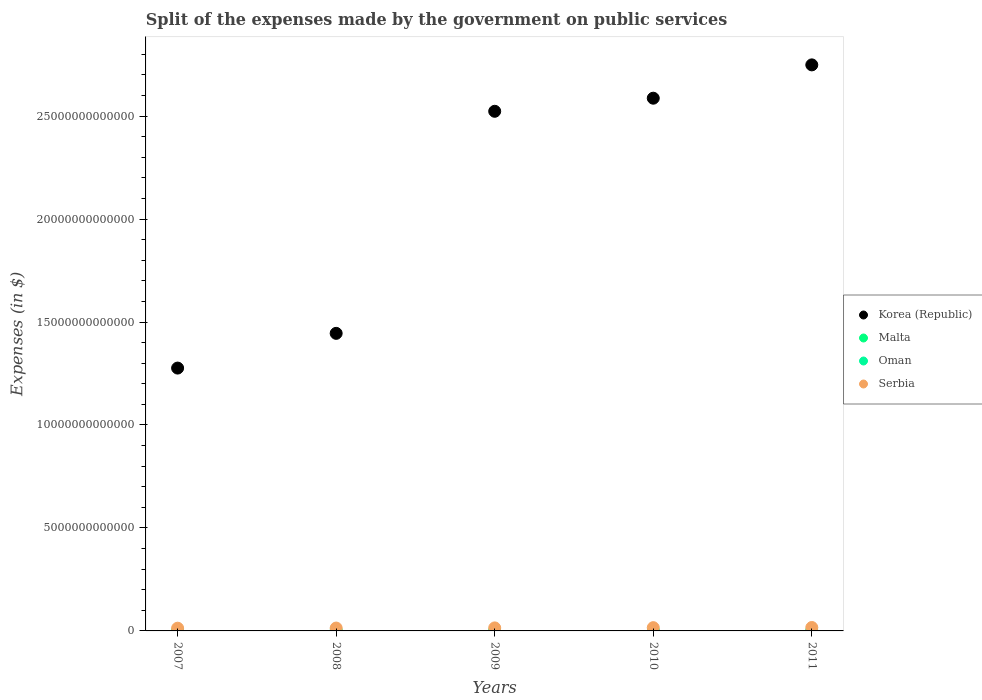What is the expenses made by the government on public services in Oman in 2011?
Offer a terse response. 3.99e+09. Across all years, what is the maximum expenses made by the government on public services in Korea (Republic)?
Provide a short and direct response. 2.75e+13. Across all years, what is the minimum expenses made by the government on public services in Oman?
Offer a very short reply. 2.47e+09. What is the total expenses made by the government on public services in Serbia in the graph?
Offer a terse response. 7.42e+11. What is the difference between the expenses made by the government on public services in Malta in 2007 and that in 2009?
Your answer should be compact. 3.03e+08. What is the difference between the expenses made by the government on public services in Oman in 2010 and the expenses made by the government on public services in Malta in 2009?
Keep it short and to the point. 2.88e+09. What is the average expenses made by the government on public services in Oman per year?
Your answer should be compact. 3.16e+09. In the year 2007, what is the difference between the expenses made by the government on public services in Serbia and expenses made by the government on public services in Malta?
Make the answer very short. 1.32e+11. What is the ratio of the expenses made by the government on public services in Malta in 2007 to that in 2009?
Ensure brevity in your answer.  1.94. What is the difference between the highest and the second highest expenses made by the government on public services in Oman?
Your response must be concise. 7.07e+08. What is the difference between the highest and the lowest expenses made by the government on public services in Serbia?
Your answer should be compact. 3.32e+1. In how many years, is the expenses made by the government on public services in Serbia greater than the average expenses made by the government on public services in Serbia taken over all years?
Your answer should be compact. 2. Is it the case that in every year, the sum of the expenses made by the government on public services in Oman and expenses made by the government on public services in Korea (Republic)  is greater than the sum of expenses made by the government on public services in Malta and expenses made by the government on public services in Serbia?
Offer a very short reply. Yes. Is the expenses made by the government on public services in Korea (Republic) strictly less than the expenses made by the government on public services in Malta over the years?
Give a very brief answer. No. What is the difference between two consecutive major ticks on the Y-axis?
Give a very brief answer. 5.00e+12. Are the values on the major ticks of Y-axis written in scientific E-notation?
Your answer should be compact. No. Does the graph contain any zero values?
Offer a terse response. No. Where does the legend appear in the graph?
Your response must be concise. Center right. How are the legend labels stacked?
Provide a succinct answer. Vertical. What is the title of the graph?
Offer a very short reply. Split of the expenses made by the government on public services. What is the label or title of the X-axis?
Give a very brief answer. Years. What is the label or title of the Y-axis?
Make the answer very short. Expenses (in $). What is the Expenses (in $) of Korea (Republic) in 2007?
Your answer should be compact. 1.28e+13. What is the Expenses (in $) in Malta in 2007?
Keep it short and to the point. 6.25e+08. What is the Expenses (in $) in Oman in 2007?
Provide a succinct answer. 2.47e+09. What is the Expenses (in $) of Serbia in 2007?
Provide a succinct answer. 1.32e+11. What is the Expenses (in $) in Korea (Republic) in 2008?
Give a very brief answer. 1.44e+13. What is the Expenses (in $) in Malta in 2008?
Provide a short and direct response. 3.59e+08. What is the Expenses (in $) of Oman in 2008?
Your answer should be compact. 3.28e+09. What is the Expenses (in $) in Serbia in 2008?
Offer a terse response. 1.39e+11. What is the Expenses (in $) in Korea (Republic) in 2009?
Your answer should be compact. 2.52e+13. What is the Expenses (in $) of Malta in 2009?
Offer a very short reply. 3.22e+08. What is the Expenses (in $) of Oman in 2009?
Give a very brief answer. 2.84e+09. What is the Expenses (in $) of Serbia in 2009?
Provide a short and direct response. 1.47e+11. What is the Expenses (in $) in Korea (Republic) in 2010?
Offer a very short reply. 2.59e+13. What is the Expenses (in $) in Malta in 2010?
Offer a very short reply. 3.41e+08. What is the Expenses (in $) of Oman in 2010?
Keep it short and to the point. 3.20e+09. What is the Expenses (in $) of Serbia in 2010?
Offer a very short reply. 1.58e+11. What is the Expenses (in $) of Korea (Republic) in 2011?
Make the answer very short. 2.75e+13. What is the Expenses (in $) of Malta in 2011?
Your answer should be compact. 3.76e+08. What is the Expenses (in $) in Oman in 2011?
Give a very brief answer. 3.99e+09. What is the Expenses (in $) of Serbia in 2011?
Keep it short and to the point. 1.66e+11. Across all years, what is the maximum Expenses (in $) of Korea (Republic)?
Offer a very short reply. 2.75e+13. Across all years, what is the maximum Expenses (in $) in Malta?
Your response must be concise. 6.25e+08. Across all years, what is the maximum Expenses (in $) in Oman?
Make the answer very short. 3.99e+09. Across all years, what is the maximum Expenses (in $) in Serbia?
Offer a very short reply. 1.66e+11. Across all years, what is the minimum Expenses (in $) in Korea (Republic)?
Your answer should be very brief. 1.28e+13. Across all years, what is the minimum Expenses (in $) in Malta?
Provide a succinct answer. 3.22e+08. Across all years, what is the minimum Expenses (in $) of Oman?
Make the answer very short. 2.47e+09. Across all years, what is the minimum Expenses (in $) of Serbia?
Ensure brevity in your answer.  1.32e+11. What is the total Expenses (in $) of Korea (Republic) in the graph?
Make the answer very short. 1.06e+14. What is the total Expenses (in $) of Malta in the graph?
Keep it short and to the point. 2.02e+09. What is the total Expenses (in $) in Oman in the graph?
Give a very brief answer. 1.58e+1. What is the total Expenses (in $) in Serbia in the graph?
Keep it short and to the point. 7.42e+11. What is the difference between the Expenses (in $) in Korea (Republic) in 2007 and that in 2008?
Provide a succinct answer. -1.69e+12. What is the difference between the Expenses (in $) of Malta in 2007 and that in 2008?
Your answer should be compact. 2.66e+08. What is the difference between the Expenses (in $) in Oman in 2007 and that in 2008?
Your response must be concise. -8.10e+08. What is the difference between the Expenses (in $) in Serbia in 2007 and that in 2008?
Ensure brevity in your answer.  -6.87e+09. What is the difference between the Expenses (in $) of Korea (Republic) in 2007 and that in 2009?
Ensure brevity in your answer.  -1.25e+13. What is the difference between the Expenses (in $) of Malta in 2007 and that in 2009?
Your response must be concise. 3.03e+08. What is the difference between the Expenses (in $) in Oman in 2007 and that in 2009?
Give a very brief answer. -3.66e+08. What is the difference between the Expenses (in $) in Serbia in 2007 and that in 2009?
Ensure brevity in your answer.  -1.44e+1. What is the difference between the Expenses (in $) in Korea (Republic) in 2007 and that in 2010?
Make the answer very short. -1.31e+13. What is the difference between the Expenses (in $) in Malta in 2007 and that in 2010?
Give a very brief answer. 2.84e+08. What is the difference between the Expenses (in $) in Oman in 2007 and that in 2010?
Offer a very short reply. -7.25e+08. What is the difference between the Expenses (in $) in Serbia in 2007 and that in 2010?
Provide a short and direct response. -2.59e+1. What is the difference between the Expenses (in $) of Korea (Republic) in 2007 and that in 2011?
Provide a short and direct response. -1.47e+13. What is the difference between the Expenses (in $) in Malta in 2007 and that in 2011?
Offer a very short reply. 2.49e+08. What is the difference between the Expenses (in $) of Oman in 2007 and that in 2011?
Make the answer very short. -1.52e+09. What is the difference between the Expenses (in $) in Serbia in 2007 and that in 2011?
Offer a very short reply. -3.32e+1. What is the difference between the Expenses (in $) in Korea (Republic) in 2008 and that in 2009?
Give a very brief answer. -1.08e+13. What is the difference between the Expenses (in $) of Malta in 2008 and that in 2009?
Offer a very short reply. 3.69e+07. What is the difference between the Expenses (in $) in Oman in 2008 and that in 2009?
Offer a very short reply. 4.44e+08. What is the difference between the Expenses (in $) of Serbia in 2008 and that in 2009?
Ensure brevity in your answer.  -7.48e+09. What is the difference between the Expenses (in $) of Korea (Republic) in 2008 and that in 2010?
Make the answer very short. -1.14e+13. What is the difference between the Expenses (in $) of Malta in 2008 and that in 2010?
Give a very brief answer. 1.82e+07. What is the difference between the Expenses (in $) of Oman in 2008 and that in 2010?
Provide a short and direct response. 8.54e+07. What is the difference between the Expenses (in $) in Serbia in 2008 and that in 2010?
Ensure brevity in your answer.  -1.90e+1. What is the difference between the Expenses (in $) in Korea (Republic) in 2008 and that in 2011?
Give a very brief answer. -1.30e+13. What is the difference between the Expenses (in $) in Malta in 2008 and that in 2011?
Give a very brief answer. -1.72e+07. What is the difference between the Expenses (in $) of Oman in 2008 and that in 2011?
Your answer should be compact. -7.07e+08. What is the difference between the Expenses (in $) of Serbia in 2008 and that in 2011?
Offer a very short reply. -2.63e+1. What is the difference between the Expenses (in $) in Korea (Republic) in 2009 and that in 2010?
Provide a short and direct response. -6.35e+11. What is the difference between the Expenses (in $) in Malta in 2009 and that in 2010?
Ensure brevity in your answer.  -1.87e+07. What is the difference between the Expenses (in $) of Oman in 2009 and that in 2010?
Make the answer very short. -3.58e+08. What is the difference between the Expenses (in $) in Serbia in 2009 and that in 2010?
Provide a succinct answer. -1.15e+1. What is the difference between the Expenses (in $) of Korea (Republic) in 2009 and that in 2011?
Your response must be concise. -2.25e+12. What is the difference between the Expenses (in $) of Malta in 2009 and that in 2011?
Provide a succinct answer. -5.41e+07. What is the difference between the Expenses (in $) of Oman in 2009 and that in 2011?
Give a very brief answer. -1.15e+09. What is the difference between the Expenses (in $) in Serbia in 2009 and that in 2011?
Give a very brief answer. -1.89e+1. What is the difference between the Expenses (in $) in Korea (Republic) in 2010 and that in 2011?
Your answer should be compact. -1.62e+12. What is the difference between the Expenses (in $) in Malta in 2010 and that in 2011?
Keep it short and to the point. -3.53e+07. What is the difference between the Expenses (in $) of Oman in 2010 and that in 2011?
Offer a very short reply. -7.93e+08. What is the difference between the Expenses (in $) of Serbia in 2010 and that in 2011?
Give a very brief answer. -7.33e+09. What is the difference between the Expenses (in $) in Korea (Republic) in 2007 and the Expenses (in $) in Malta in 2008?
Ensure brevity in your answer.  1.28e+13. What is the difference between the Expenses (in $) in Korea (Republic) in 2007 and the Expenses (in $) in Oman in 2008?
Keep it short and to the point. 1.28e+13. What is the difference between the Expenses (in $) in Korea (Republic) in 2007 and the Expenses (in $) in Serbia in 2008?
Ensure brevity in your answer.  1.26e+13. What is the difference between the Expenses (in $) of Malta in 2007 and the Expenses (in $) of Oman in 2008?
Provide a short and direct response. -2.66e+09. What is the difference between the Expenses (in $) in Malta in 2007 and the Expenses (in $) in Serbia in 2008?
Your response must be concise. -1.39e+11. What is the difference between the Expenses (in $) of Oman in 2007 and the Expenses (in $) of Serbia in 2008?
Keep it short and to the point. -1.37e+11. What is the difference between the Expenses (in $) of Korea (Republic) in 2007 and the Expenses (in $) of Malta in 2009?
Provide a succinct answer. 1.28e+13. What is the difference between the Expenses (in $) of Korea (Republic) in 2007 and the Expenses (in $) of Oman in 2009?
Your response must be concise. 1.28e+13. What is the difference between the Expenses (in $) of Korea (Republic) in 2007 and the Expenses (in $) of Serbia in 2009?
Provide a succinct answer. 1.26e+13. What is the difference between the Expenses (in $) of Malta in 2007 and the Expenses (in $) of Oman in 2009?
Provide a short and direct response. -2.22e+09. What is the difference between the Expenses (in $) in Malta in 2007 and the Expenses (in $) in Serbia in 2009?
Ensure brevity in your answer.  -1.46e+11. What is the difference between the Expenses (in $) of Oman in 2007 and the Expenses (in $) of Serbia in 2009?
Offer a terse response. -1.44e+11. What is the difference between the Expenses (in $) in Korea (Republic) in 2007 and the Expenses (in $) in Malta in 2010?
Ensure brevity in your answer.  1.28e+13. What is the difference between the Expenses (in $) of Korea (Republic) in 2007 and the Expenses (in $) of Oman in 2010?
Make the answer very short. 1.28e+13. What is the difference between the Expenses (in $) in Korea (Republic) in 2007 and the Expenses (in $) in Serbia in 2010?
Your answer should be very brief. 1.26e+13. What is the difference between the Expenses (in $) in Malta in 2007 and the Expenses (in $) in Oman in 2010?
Keep it short and to the point. -2.57e+09. What is the difference between the Expenses (in $) in Malta in 2007 and the Expenses (in $) in Serbia in 2010?
Ensure brevity in your answer.  -1.58e+11. What is the difference between the Expenses (in $) in Oman in 2007 and the Expenses (in $) in Serbia in 2010?
Ensure brevity in your answer.  -1.56e+11. What is the difference between the Expenses (in $) in Korea (Republic) in 2007 and the Expenses (in $) in Malta in 2011?
Make the answer very short. 1.28e+13. What is the difference between the Expenses (in $) in Korea (Republic) in 2007 and the Expenses (in $) in Oman in 2011?
Make the answer very short. 1.28e+13. What is the difference between the Expenses (in $) of Korea (Republic) in 2007 and the Expenses (in $) of Serbia in 2011?
Make the answer very short. 1.26e+13. What is the difference between the Expenses (in $) in Malta in 2007 and the Expenses (in $) in Oman in 2011?
Offer a very short reply. -3.37e+09. What is the difference between the Expenses (in $) of Malta in 2007 and the Expenses (in $) of Serbia in 2011?
Offer a terse response. -1.65e+11. What is the difference between the Expenses (in $) of Oman in 2007 and the Expenses (in $) of Serbia in 2011?
Give a very brief answer. -1.63e+11. What is the difference between the Expenses (in $) of Korea (Republic) in 2008 and the Expenses (in $) of Malta in 2009?
Offer a very short reply. 1.44e+13. What is the difference between the Expenses (in $) in Korea (Republic) in 2008 and the Expenses (in $) in Oman in 2009?
Offer a terse response. 1.44e+13. What is the difference between the Expenses (in $) in Korea (Republic) in 2008 and the Expenses (in $) in Serbia in 2009?
Offer a terse response. 1.43e+13. What is the difference between the Expenses (in $) of Malta in 2008 and the Expenses (in $) of Oman in 2009?
Offer a terse response. -2.48e+09. What is the difference between the Expenses (in $) in Malta in 2008 and the Expenses (in $) in Serbia in 2009?
Offer a very short reply. -1.46e+11. What is the difference between the Expenses (in $) in Oman in 2008 and the Expenses (in $) in Serbia in 2009?
Offer a very short reply. -1.43e+11. What is the difference between the Expenses (in $) in Korea (Republic) in 2008 and the Expenses (in $) in Malta in 2010?
Provide a short and direct response. 1.44e+13. What is the difference between the Expenses (in $) of Korea (Republic) in 2008 and the Expenses (in $) of Oman in 2010?
Your answer should be very brief. 1.44e+13. What is the difference between the Expenses (in $) in Korea (Republic) in 2008 and the Expenses (in $) in Serbia in 2010?
Make the answer very short. 1.43e+13. What is the difference between the Expenses (in $) in Malta in 2008 and the Expenses (in $) in Oman in 2010?
Offer a terse response. -2.84e+09. What is the difference between the Expenses (in $) in Malta in 2008 and the Expenses (in $) in Serbia in 2010?
Provide a short and direct response. -1.58e+11. What is the difference between the Expenses (in $) in Oman in 2008 and the Expenses (in $) in Serbia in 2010?
Offer a very short reply. -1.55e+11. What is the difference between the Expenses (in $) in Korea (Republic) in 2008 and the Expenses (in $) in Malta in 2011?
Make the answer very short. 1.44e+13. What is the difference between the Expenses (in $) in Korea (Republic) in 2008 and the Expenses (in $) in Oman in 2011?
Offer a very short reply. 1.44e+13. What is the difference between the Expenses (in $) in Korea (Republic) in 2008 and the Expenses (in $) in Serbia in 2011?
Offer a terse response. 1.43e+13. What is the difference between the Expenses (in $) of Malta in 2008 and the Expenses (in $) of Oman in 2011?
Give a very brief answer. -3.63e+09. What is the difference between the Expenses (in $) in Malta in 2008 and the Expenses (in $) in Serbia in 2011?
Your answer should be compact. -1.65e+11. What is the difference between the Expenses (in $) in Oman in 2008 and the Expenses (in $) in Serbia in 2011?
Offer a terse response. -1.62e+11. What is the difference between the Expenses (in $) of Korea (Republic) in 2009 and the Expenses (in $) of Malta in 2010?
Make the answer very short. 2.52e+13. What is the difference between the Expenses (in $) in Korea (Republic) in 2009 and the Expenses (in $) in Oman in 2010?
Make the answer very short. 2.52e+13. What is the difference between the Expenses (in $) in Korea (Republic) in 2009 and the Expenses (in $) in Serbia in 2010?
Give a very brief answer. 2.51e+13. What is the difference between the Expenses (in $) of Malta in 2009 and the Expenses (in $) of Oman in 2010?
Make the answer very short. -2.88e+09. What is the difference between the Expenses (in $) of Malta in 2009 and the Expenses (in $) of Serbia in 2010?
Your answer should be very brief. -1.58e+11. What is the difference between the Expenses (in $) in Oman in 2009 and the Expenses (in $) in Serbia in 2010?
Your answer should be very brief. -1.55e+11. What is the difference between the Expenses (in $) in Korea (Republic) in 2009 and the Expenses (in $) in Malta in 2011?
Keep it short and to the point. 2.52e+13. What is the difference between the Expenses (in $) of Korea (Republic) in 2009 and the Expenses (in $) of Oman in 2011?
Your response must be concise. 2.52e+13. What is the difference between the Expenses (in $) of Korea (Republic) in 2009 and the Expenses (in $) of Serbia in 2011?
Your answer should be very brief. 2.51e+13. What is the difference between the Expenses (in $) in Malta in 2009 and the Expenses (in $) in Oman in 2011?
Your answer should be compact. -3.67e+09. What is the difference between the Expenses (in $) of Malta in 2009 and the Expenses (in $) of Serbia in 2011?
Make the answer very short. -1.65e+11. What is the difference between the Expenses (in $) in Oman in 2009 and the Expenses (in $) in Serbia in 2011?
Ensure brevity in your answer.  -1.63e+11. What is the difference between the Expenses (in $) in Korea (Republic) in 2010 and the Expenses (in $) in Malta in 2011?
Make the answer very short. 2.59e+13. What is the difference between the Expenses (in $) of Korea (Republic) in 2010 and the Expenses (in $) of Oman in 2011?
Your answer should be compact. 2.59e+13. What is the difference between the Expenses (in $) in Korea (Republic) in 2010 and the Expenses (in $) in Serbia in 2011?
Offer a terse response. 2.57e+13. What is the difference between the Expenses (in $) in Malta in 2010 and the Expenses (in $) in Oman in 2011?
Offer a very short reply. -3.65e+09. What is the difference between the Expenses (in $) in Malta in 2010 and the Expenses (in $) in Serbia in 2011?
Your response must be concise. -1.65e+11. What is the difference between the Expenses (in $) of Oman in 2010 and the Expenses (in $) of Serbia in 2011?
Offer a terse response. -1.62e+11. What is the average Expenses (in $) in Korea (Republic) per year?
Provide a succinct answer. 2.12e+13. What is the average Expenses (in $) in Malta per year?
Give a very brief answer. 4.05e+08. What is the average Expenses (in $) in Oman per year?
Keep it short and to the point. 3.16e+09. What is the average Expenses (in $) in Serbia per year?
Keep it short and to the point. 1.48e+11. In the year 2007, what is the difference between the Expenses (in $) in Korea (Republic) and Expenses (in $) in Malta?
Offer a very short reply. 1.28e+13. In the year 2007, what is the difference between the Expenses (in $) of Korea (Republic) and Expenses (in $) of Oman?
Provide a succinct answer. 1.28e+13. In the year 2007, what is the difference between the Expenses (in $) in Korea (Republic) and Expenses (in $) in Serbia?
Offer a terse response. 1.26e+13. In the year 2007, what is the difference between the Expenses (in $) of Malta and Expenses (in $) of Oman?
Your response must be concise. -1.85e+09. In the year 2007, what is the difference between the Expenses (in $) in Malta and Expenses (in $) in Serbia?
Your answer should be very brief. -1.32e+11. In the year 2007, what is the difference between the Expenses (in $) in Oman and Expenses (in $) in Serbia?
Make the answer very short. -1.30e+11. In the year 2008, what is the difference between the Expenses (in $) of Korea (Republic) and Expenses (in $) of Malta?
Offer a very short reply. 1.44e+13. In the year 2008, what is the difference between the Expenses (in $) in Korea (Republic) and Expenses (in $) in Oman?
Make the answer very short. 1.44e+13. In the year 2008, what is the difference between the Expenses (in $) of Korea (Republic) and Expenses (in $) of Serbia?
Make the answer very short. 1.43e+13. In the year 2008, what is the difference between the Expenses (in $) of Malta and Expenses (in $) of Oman?
Offer a terse response. -2.93e+09. In the year 2008, what is the difference between the Expenses (in $) in Malta and Expenses (in $) in Serbia?
Provide a short and direct response. -1.39e+11. In the year 2008, what is the difference between the Expenses (in $) of Oman and Expenses (in $) of Serbia?
Provide a succinct answer. -1.36e+11. In the year 2009, what is the difference between the Expenses (in $) in Korea (Republic) and Expenses (in $) in Malta?
Make the answer very short. 2.52e+13. In the year 2009, what is the difference between the Expenses (in $) in Korea (Republic) and Expenses (in $) in Oman?
Offer a terse response. 2.52e+13. In the year 2009, what is the difference between the Expenses (in $) of Korea (Republic) and Expenses (in $) of Serbia?
Ensure brevity in your answer.  2.51e+13. In the year 2009, what is the difference between the Expenses (in $) in Malta and Expenses (in $) in Oman?
Provide a succinct answer. -2.52e+09. In the year 2009, what is the difference between the Expenses (in $) in Malta and Expenses (in $) in Serbia?
Offer a very short reply. -1.46e+11. In the year 2009, what is the difference between the Expenses (in $) in Oman and Expenses (in $) in Serbia?
Make the answer very short. -1.44e+11. In the year 2010, what is the difference between the Expenses (in $) of Korea (Republic) and Expenses (in $) of Malta?
Give a very brief answer. 2.59e+13. In the year 2010, what is the difference between the Expenses (in $) in Korea (Republic) and Expenses (in $) in Oman?
Your answer should be compact. 2.59e+13. In the year 2010, what is the difference between the Expenses (in $) of Korea (Republic) and Expenses (in $) of Serbia?
Keep it short and to the point. 2.57e+13. In the year 2010, what is the difference between the Expenses (in $) in Malta and Expenses (in $) in Oman?
Your answer should be very brief. -2.86e+09. In the year 2010, what is the difference between the Expenses (in $) in Malta and Expenses (in $) in Serbia?
Offer a very short reply. -1.58e+11. In the year 2010, what is the difference between the Expenses (in $) in Oman and Expenses (in $) in Serbia?
Offer a terse response. -1.55e+11. In the year 2011, what is the difference between the Expenses (in $) in Korea (Republic) and Expenses (in $) in Malta?
Keep it short and to the point. 2.75e+13. In the year 2011, what is the difference between the Expenses (in $) in Korea (Republic) and Expenses (in $) in Oman?
Keep it short and to the point. 2.75e+13. In the year 2011, what is the difference between the Expenses (in $) in Korea (Republic) and Expenses (in $) in Serbia?
Keep it short and to the point. 2.73e+13. In the year 2011, what is the difference between the Expenses (in $) in Malta and Expenses (in $) in Oman?
Your response must be concise. -3.62e+09. In the year 2011, what is the difference between the Expenses (in $) in Malta and Expenses (in $) in Serbia?
Provide a succinct answer. -1.65e+11. In the year 2011, what is the difference between the Expenses (in $) in Oman and Expenses (in $) in Serbia?
Offer a terse response. -1.62e+11. What is the ratio of the Expenses (in $) of Korea (Republic) in 2007 to that in 2008?
Your answer should be compact. 0.88. What is the ratio of the Expenses (in $) of Malta in 2007 to that in 2008?
Your answer should be compact. 1.74. What is the ratio of the Expenses (in $) of Oman in 2007 to that in 2008?
Provide a short and direct response. 0.75. What is the ratio of the Expenses (in $) in Serbia in 2007 to that in 2008?
Provide a succinct answer. 0.95. What is the ratio of the Expenses (in $) of Korea (Republic) in 2007 to that in 2009?
Ensure brevity in your answer.  0.51. What is the ratio of the Expenses (in $) in Malta in 2007 to that in 2009?
Keep it short and to the point. 1.94. What is the ratio of the Expenses (in $) of Oman in 2007 to that in 2009?
Make the answer very short. 0.87. What is the ratio of the Expenses (in $) in Serbia in 2007 to that in 2009?
Make the answer very short. 0.9. What is the ratio of the Expenses (in $) of Korea (Republic) in 2007 to that in 2010?
Your answer should be very brief. 0.49. What is the ratio of the Expenses (in $) in Malta in 2007 to that in 2010?
Your answer should be very brief. 1.83. What is the ratio of the Expenses (in $) of Oman in 2007 to that in 2010?
Offer a terse response. 0.77. What is the ratio of the Expenses (in $) of Serbia in 2007 to that in 2010?
Your answer should be very brief. 0.84. What is the ratio of the Expenses (in $) of Korea (Republic) in 2007 to that in 2011?
Provide a succinct answer. 0.46. What is the ratio of the Expenses (in $) of Malta in 2007 to that in 2011?
Your answer should be compact. 1.66. What is the ratio of the Expenses (in $) of Oman in 2007 to that in 2011?
Your answer should be very brief. 0.62. What is the ratio of the Expenses (in $) of Serbia in 2007 to that in 2011?
Offer a very short reply. 0.8. What is the ratio of the Expenses (in $) in Korea (Republic) in 2008 to that in 2009?
Offer a terse response. 0.57. What is the ratio of the Expenses (in $) in Malta in 2008 to that in 2009?
Your response must be concise. 1.11. What is the ratio of the Expenses (in $) of Oman in 2008 to that in 2009?
Your answer should be compact. 1.16. What is the ratio of the Expenses (in $) in Serbia in 2008 to that in 2009?
Your answer should be compact. 0.95. What is the ratio of the Expenses (in $) in Korea (Republic) in 2008 to that in 2010?
Provide a succinct answer. 0.56. What is the ratio of the Expenses (in $) in Malta in 2008 to that in 2010?
Make the answer very short. 1.05. What is the ratio of the Expenses (in $) in Oman in 2008 to that in 2010?
Your response must be concise. 1.03. What is the ratio of the Expenses (in $) in Serbia in 2008 to that in 2010?
Ensure brevity in your answer.  0.88. What is the ratio of the Expenses (in $) of Korea (Republic) in 2008 to that in 2011?
Provide a short and direct response. 0.53. What is the ratio of the Expenses (in $) in Malta in 2008 to that in 2011?
Your answer should be compact. 0.95. What is the ratio of the Expenses (in $) of Oman in 2008 to that in 2011?
Give a very brief answer. 0.82. What is the ratio of the Expenses (in $) of Serbia in 2008 to that in 2011?
Offer a very short reply. 0.84. What is the ratio of the Expenses (in $) of Korea (Republic) in 2009 to that in 2010?
Provide a succinct answer. 0.98. What is the ratio of the Expenses (in $) in Malta in 2009 to that in 2010?
Give a very brief answer. 0.95. What is the ratio of the Expenses (in $) of Oman in 2009 to that in 2010?
Your answer should be compact. 0.89. What is the ratio of the Expenses (in $) of Serbia in 2009 to that in 2010?
Provide a succinct answer. 0.93. What is the ratio of the Expenses (in $) of Korea (Republic) in 2009 to that in 2011?
Your response must be concise. 0.92. What is the ratio of the Expenses (in $) in Malta in 2009 to that in 2011?
Make the answer very short. 0.86. What is the ratio of the Expenses (in $) in Oman in 2009 to that in 2011?
Your answer should be very brief. 0.71. What is the ratio of the Expenses (in $) in Serbia in 2009 to that in 2011?
Make the answer very short. 0.89. What is the ratio of the Expenses (in $) of Korea (Republic) in 2010 to that in 2011?
Provide a succinct answer. 0.94. What is the ratio of the Expenses (in $) in Malta in 2010 to that in 2011?
Offer a terse response. 0.91. What is the ratio of the Expenses (in $) of Oman in 2010 to that in 2011?
Provide a succinct answer. 0.8. What is the ratio of the Expenses (in $) of Serbia in 2010 to that in 2011?
Your answer should be compact. 0.96. What is the difference between the highest and the second highest Expenses (in $) of Korea (Republic)?
Ensure brevity in your answer.  1.62e+12. What is the difference between the highest and the second highest Expenses (in $) of Malta?
Provide a short and direct response. 2.49e+08. What is the difference between the highest and the second highest Expenses (in $) of Oman?
Give a very brief answer. 7.07e+08. What is the difference between the highest and the second highest Expenses (in $) of Serbia?
Provide a succinct answer. 7.33e+09. What is the difference between the highest and the lowest Expenses (in $) of Korea (Republic)?
Provide a succinct answer. 1.47e+13. What is the difference between the highest and the lowest Expenses (in $) in Malta?
Give a very brief answer. 3.03e+08. What is the difference between the highest and the lowest Expenses (in $) of Oman?
Ensure brevity in your answer.  1.52e+09. What is the difference between the highest and the lowest Expenses (in $) in Serbia?
Keep it short and to the point. 3.32e+1. 